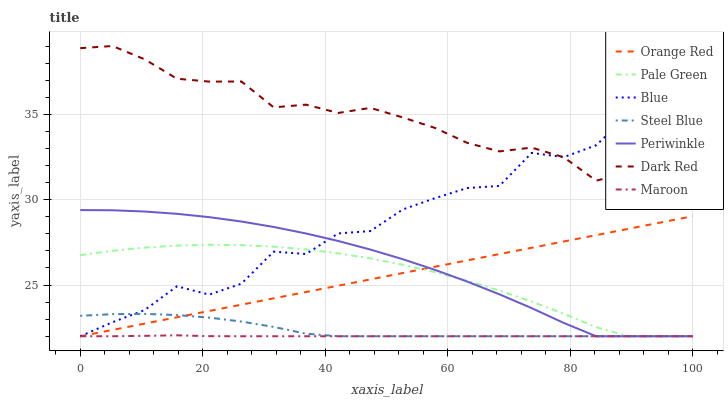Does Maroon have the minimum area under the curve?
Answer yes or no. Yes. Does Dark Red have the maximum area under the curve?
Answer yes or no. Yes. Does Steel Blue have the minimum area under the curve?
Answer yes or no. No. Does Steel Blue have the maximum area under the curve?
Answer yes or no. No. Is Orange Red the smoothest?
Answer yes or no. Yes. Is Blue the roughest?
Answer yes or no. Yes. Is Dark Red the smoothest?
Answer yes or no. No. Is Dark Red the roughest?
Answer yes or no. No. Does Blue have the lowest value?
Answer yes or no. Yes. Does Dark Red have the lowest value?
Answer yes or no. No. Does Dark Red have the highest value?
Answer yes or no. Yes. Does Steel Blue have the highest value?
Answer yes or no. No. Is Orange Red less than Dark Red?
Answer yes or no. Yes. Is Dark Red greater than Steel Blue?
Answer yes or no. Yes. Does Steel Blue intersect Periwinkle?
Answer yes or no. Yes. Is Steel Blue less than Periwinkle?
Answer yes or no. No. Is Steel Blue greater than Periwinkle?
Answer yes or no. No. Does Orange Red intersect Dark Red?
Answer yes or no. No. 